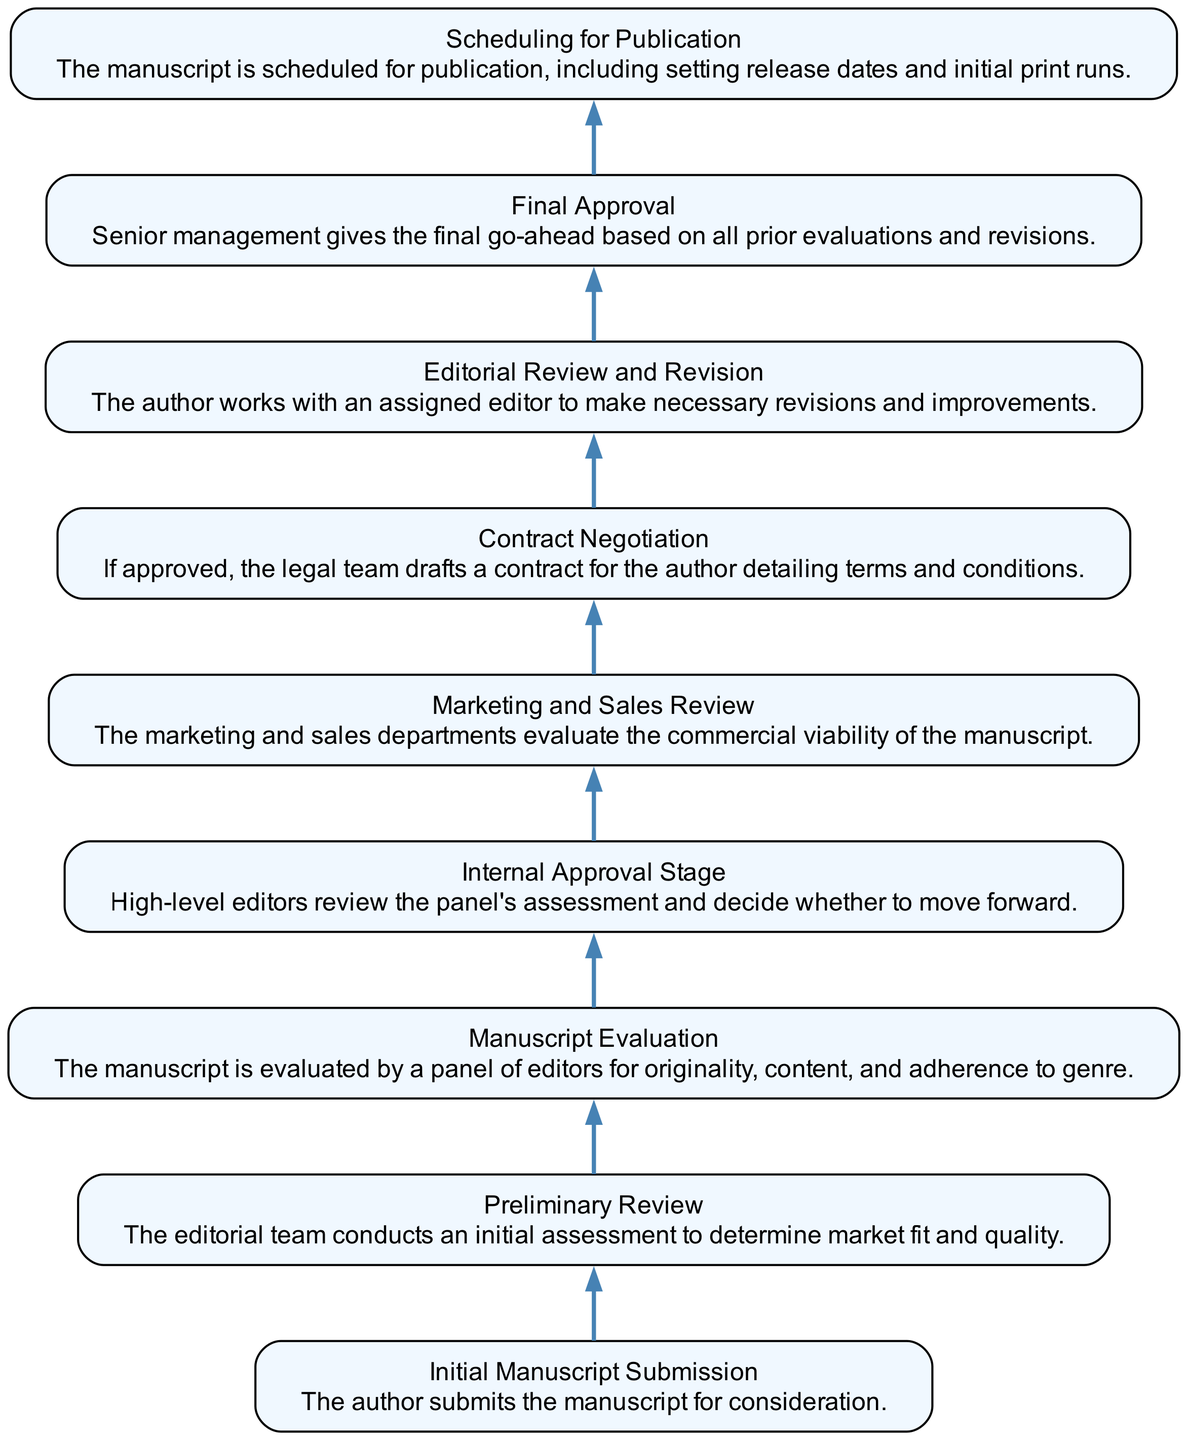What is the first step in the Editorial Approval Process? The first step is "Initial Manuscript Submission," where the author submits the manuscript for consideration. This is directly indicated as the starting point at the bottom of the flow chart.
Answer: Initial Manuscript Submission How many main stages are there in the process? There are nine main stages, as indicated by the nine nodes in the flow chart, each representing a different step in the editorial approval process.
Answer: 9 Which stage comes after the Internal Approval Stage? The stage that follows the Internal Approval Stage is the "Marketing and Sales Review," as shown by the upward connection between these two nodes in the diagram.
Answer: Marketing and Sales Review What is the role of the Marketing and Sales Review? The purpose of the Marketing and Sales Review is to evaluate the commercial viability of the manuscript. This is stated in the node related to this stage in the diagram.
Answer: Evaluate the commercial viability Which step directly precedes the Final Approval stage? The step that comes directly before the Final Approval is "Editorial Review and Revision," indicating that comprehensive edits and improvements happen before finalizing the manuscript for publication.
Answer: Editorial Review and Revision What does the Contract Negotiation stage involve? The Contract Negotiation stage involves the legal team drafting a contract for the author detailing terms and conditions, as per the description in the respective node of the flow chart.
Answer: Legal team drafts a contract Which stage requires author cooperation? The stage that requires the author's cooperation is "Editorial Review and Revision," where the author works with an assigned editor to make necessary revisions and improvements. This is explicitly mentioned in the description for that node.
Answer: Editorial Review and Revision What is the final action taken in the process? The final action taken in the process is "Scheduling for Publication," indicating that the manuscript is set for publication with release dates and print runs arranged. This is the last node in the flow chart.
Answer: Scheduling for Publication 